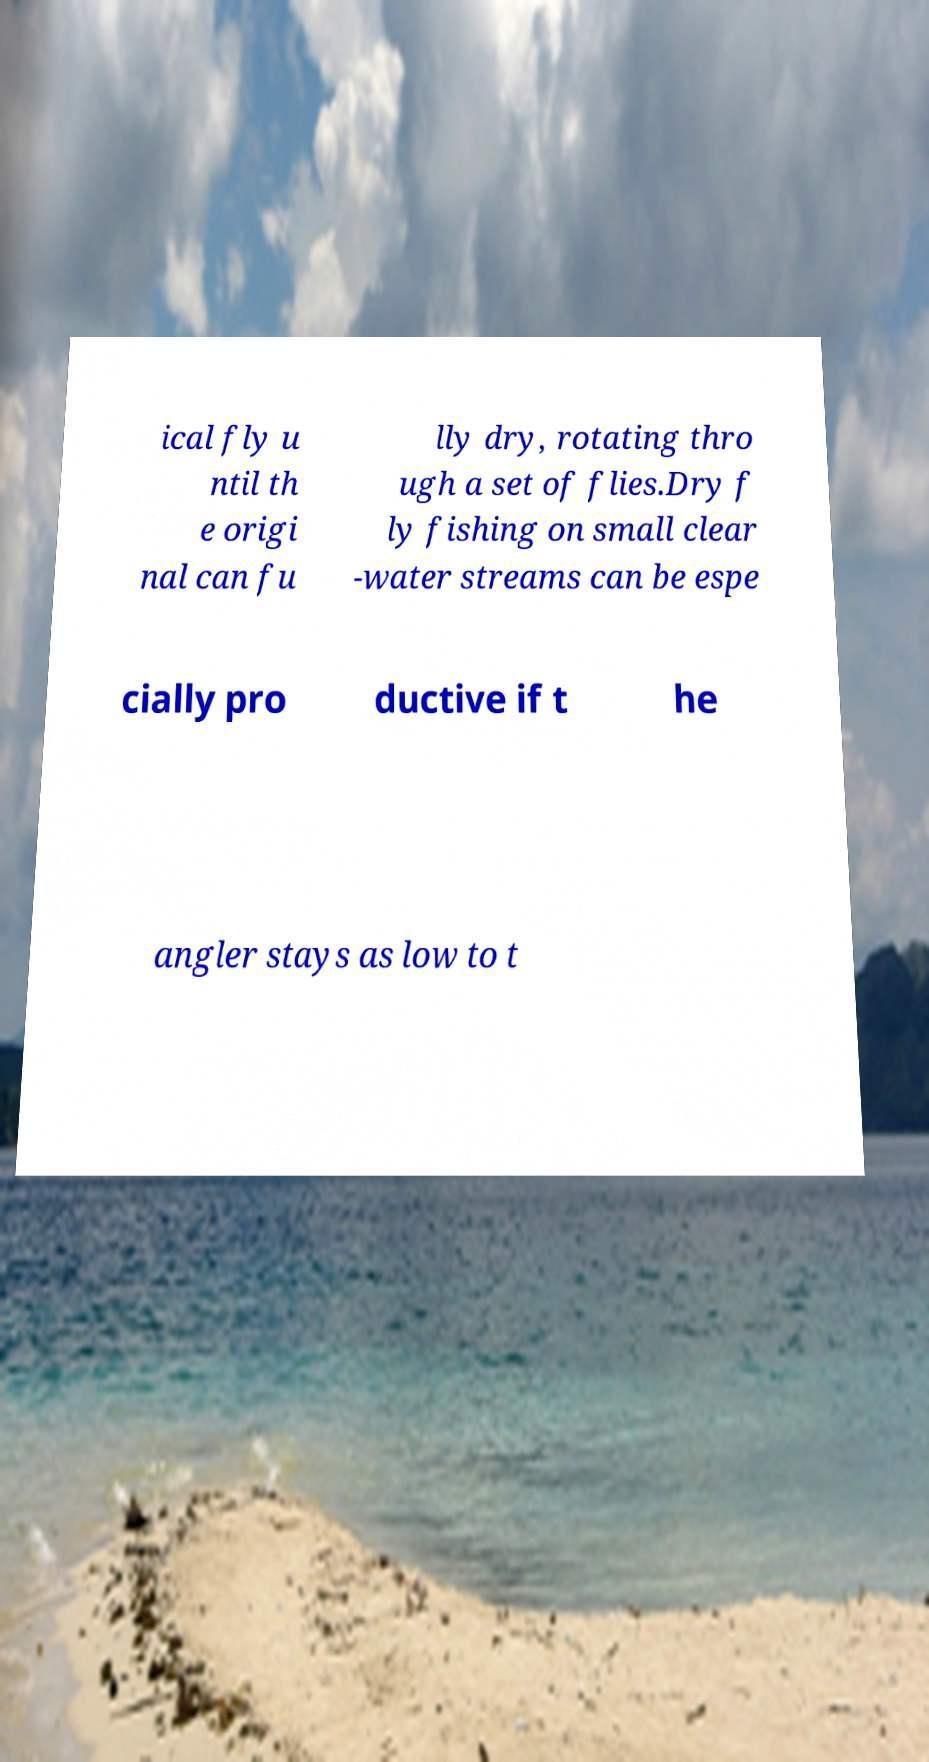Could you assist in decoding the text presented in this image and type it out clearly? ical fly u ntil th e origi nal can fu lly dry, rotating thro ugh a set of flies.Dry f ly fishing on small clear -water streams can be espe cially pro ductive if t he angler stays as low to t 